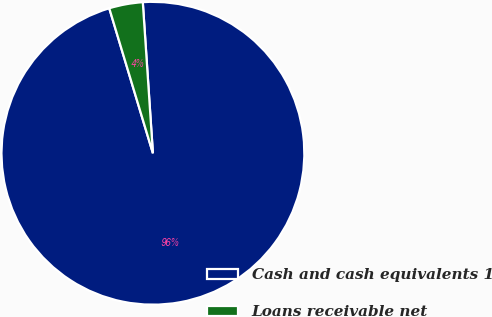<chart> <loc_0><loc_0><loc_500><loc_500><pie_chart><fcel>Cash and cash equivalents 1<fcel>Loans receivable net<nl><fcel>96.41%<fcel>3.59%<nl></chart> 